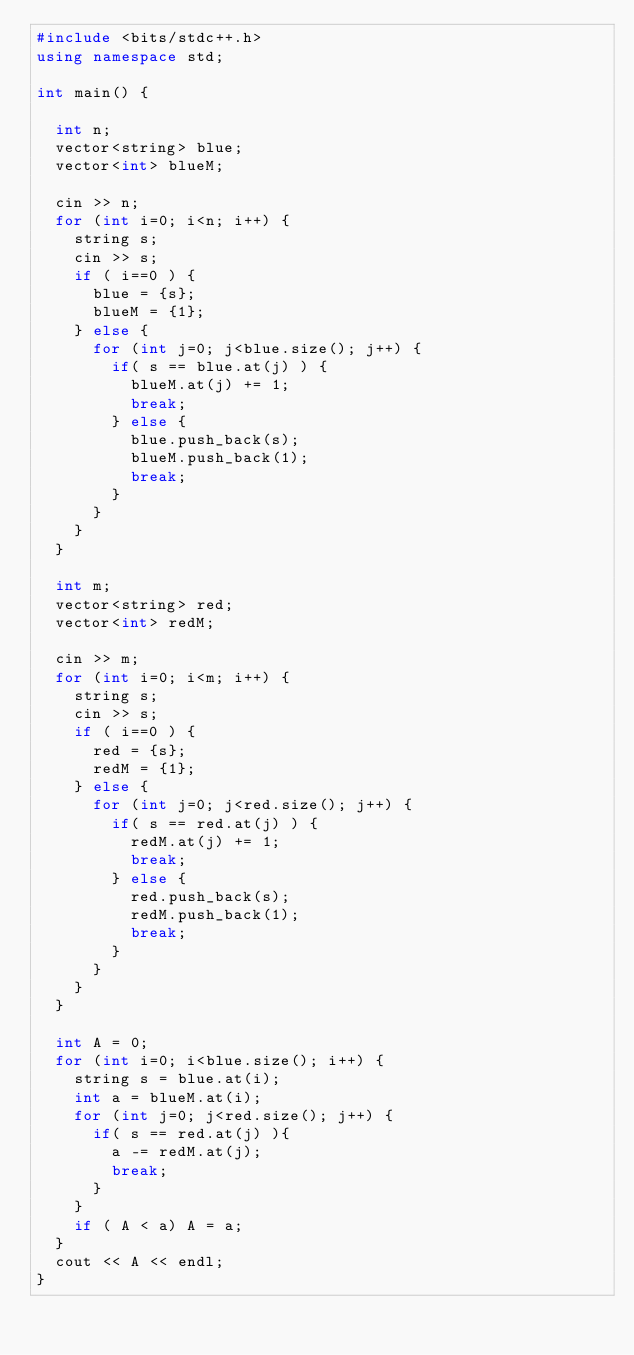<code> <loc_0><loc_0><loc_500><loc_500><_C++_>#include <bits/stdc++.h>
using namespace std;

int main() {

  int n;  
  vector<string> blue;
  vector<int> blueM;

  cin >> n;
  for (int i=0; i<n; i++) {
    string s;
    cin >> s;
    if ( i==0 ) {
      blue = {s};        
      blueM = {1};
    } else {
      for (int j=0; j<blue.size(); j++) {
        if( s == blue.at(j) ) {
          blueM.at(j) += 1;
          break;
        } else {
          blue.push_back(s);
          blueM.push_back(1);
          break;
        }
      }      
    }  
  }

  int m;  
  vector<string> red;
  vector<int> redM;

  cin >> m;
  for (int i=0; i<m; i++) {
    string s;
    cin >> s;
    if ( i==0 ) {
      red = {s};        
      redM = {1};
    } else {
      for (int j=0; j<red.size(); j++) {
        if( s == red.at(j) ) {
          redM.at(j) += 1;
          break;
        } else {
          red.push_back(s);
          redM.push_back(1);
          break;
        }
      }      
    }  
  }
  
  int A = 0;
  for (int i=0; i<blue.size(); i++) {
    string s = blue.at(i);
    int a = blueM.at(i);
    for (int j=0; j<red.size(); j++) {
      if( s == red.at(j) ){
        a -= redM.at(j);
        break;
      }
    }
    if ( A < a) A = a;
  }
  cout << A << endl;
}
 </code> 